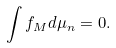<formula> <loc_0><loc_0><loc_500><loc_500>\int f _ { M } d \mu _ { n } = 0 .</formula> 